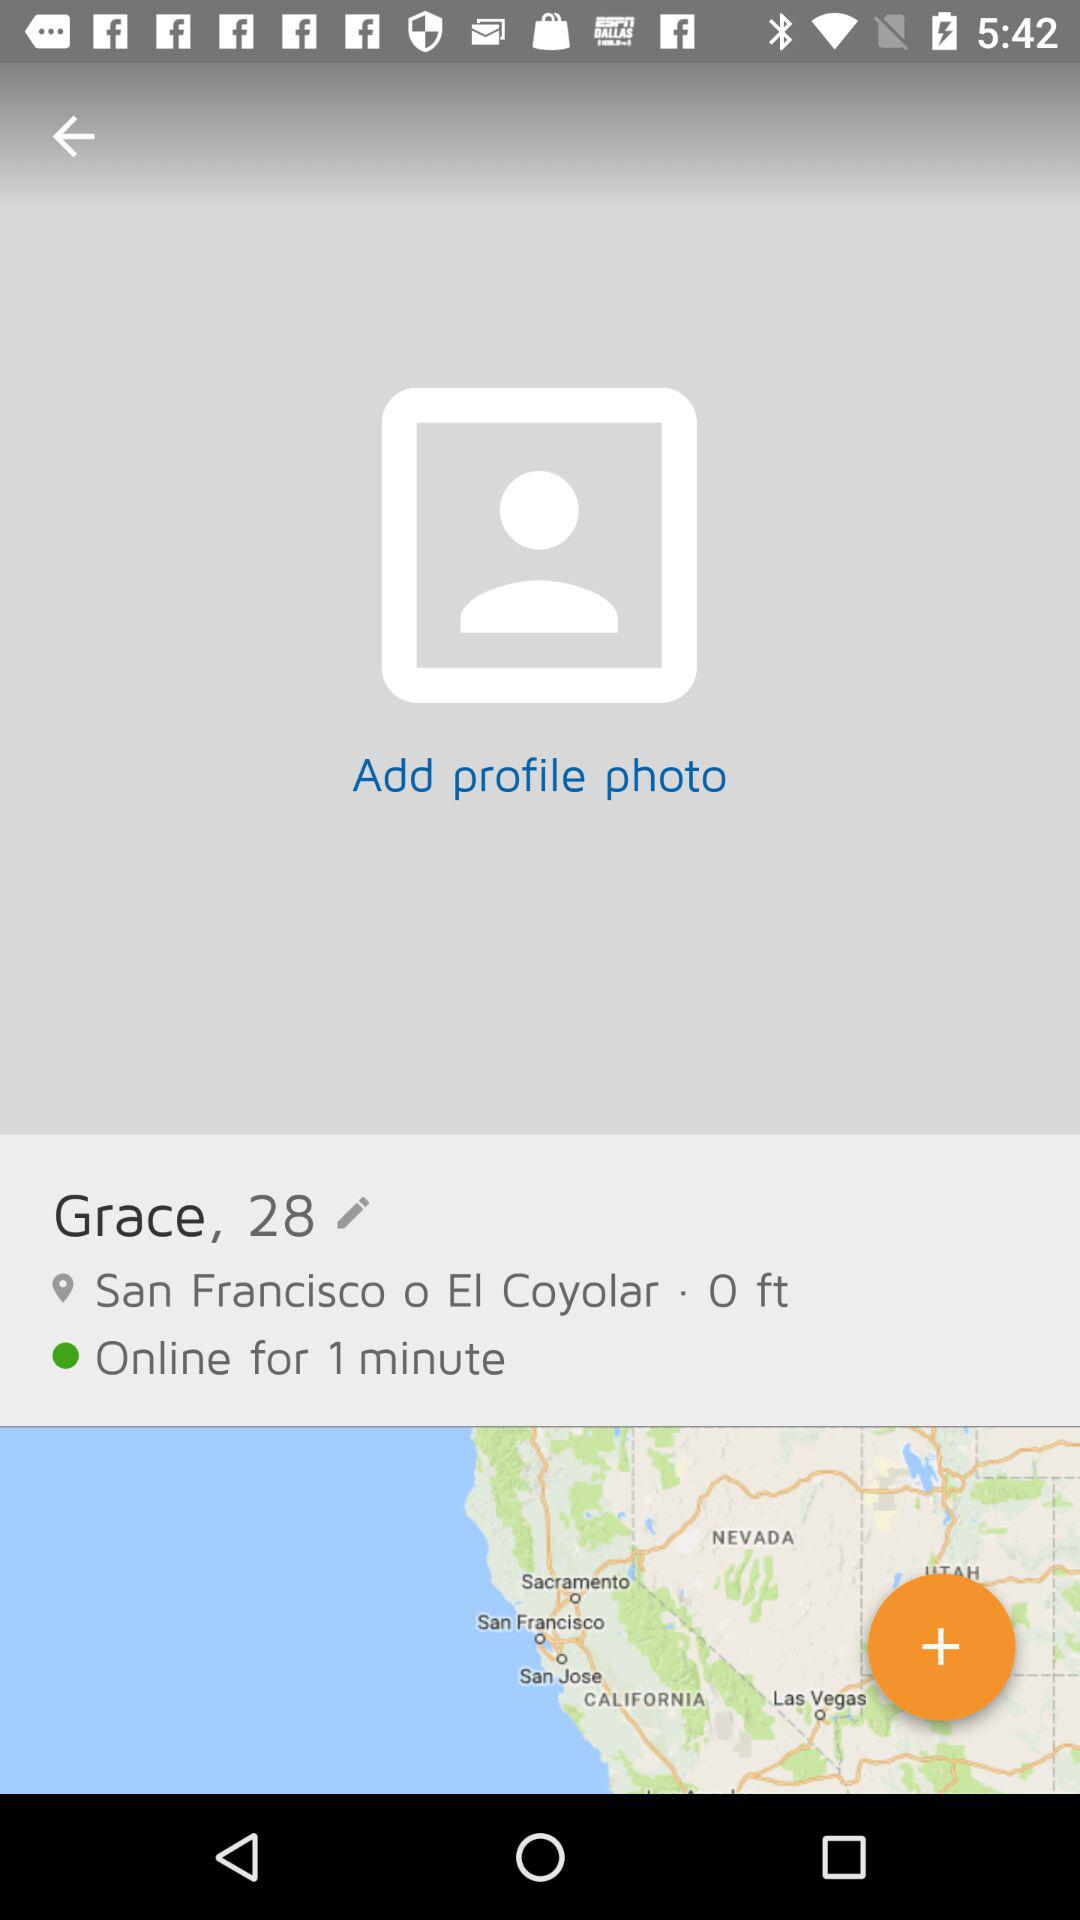What was the status for one minute? The status was online for one minute. 